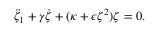<formula> <loc_0><loc_0><loc_500><loc_500>\begin{array} { r } { \ddot { \zeta } _ { 1 } + \gamma \dot { \zeta } + ( \kappa + \epsilon \zeta ^ { 2 } ) \zeta = 0 . } \end{array}</formula> 